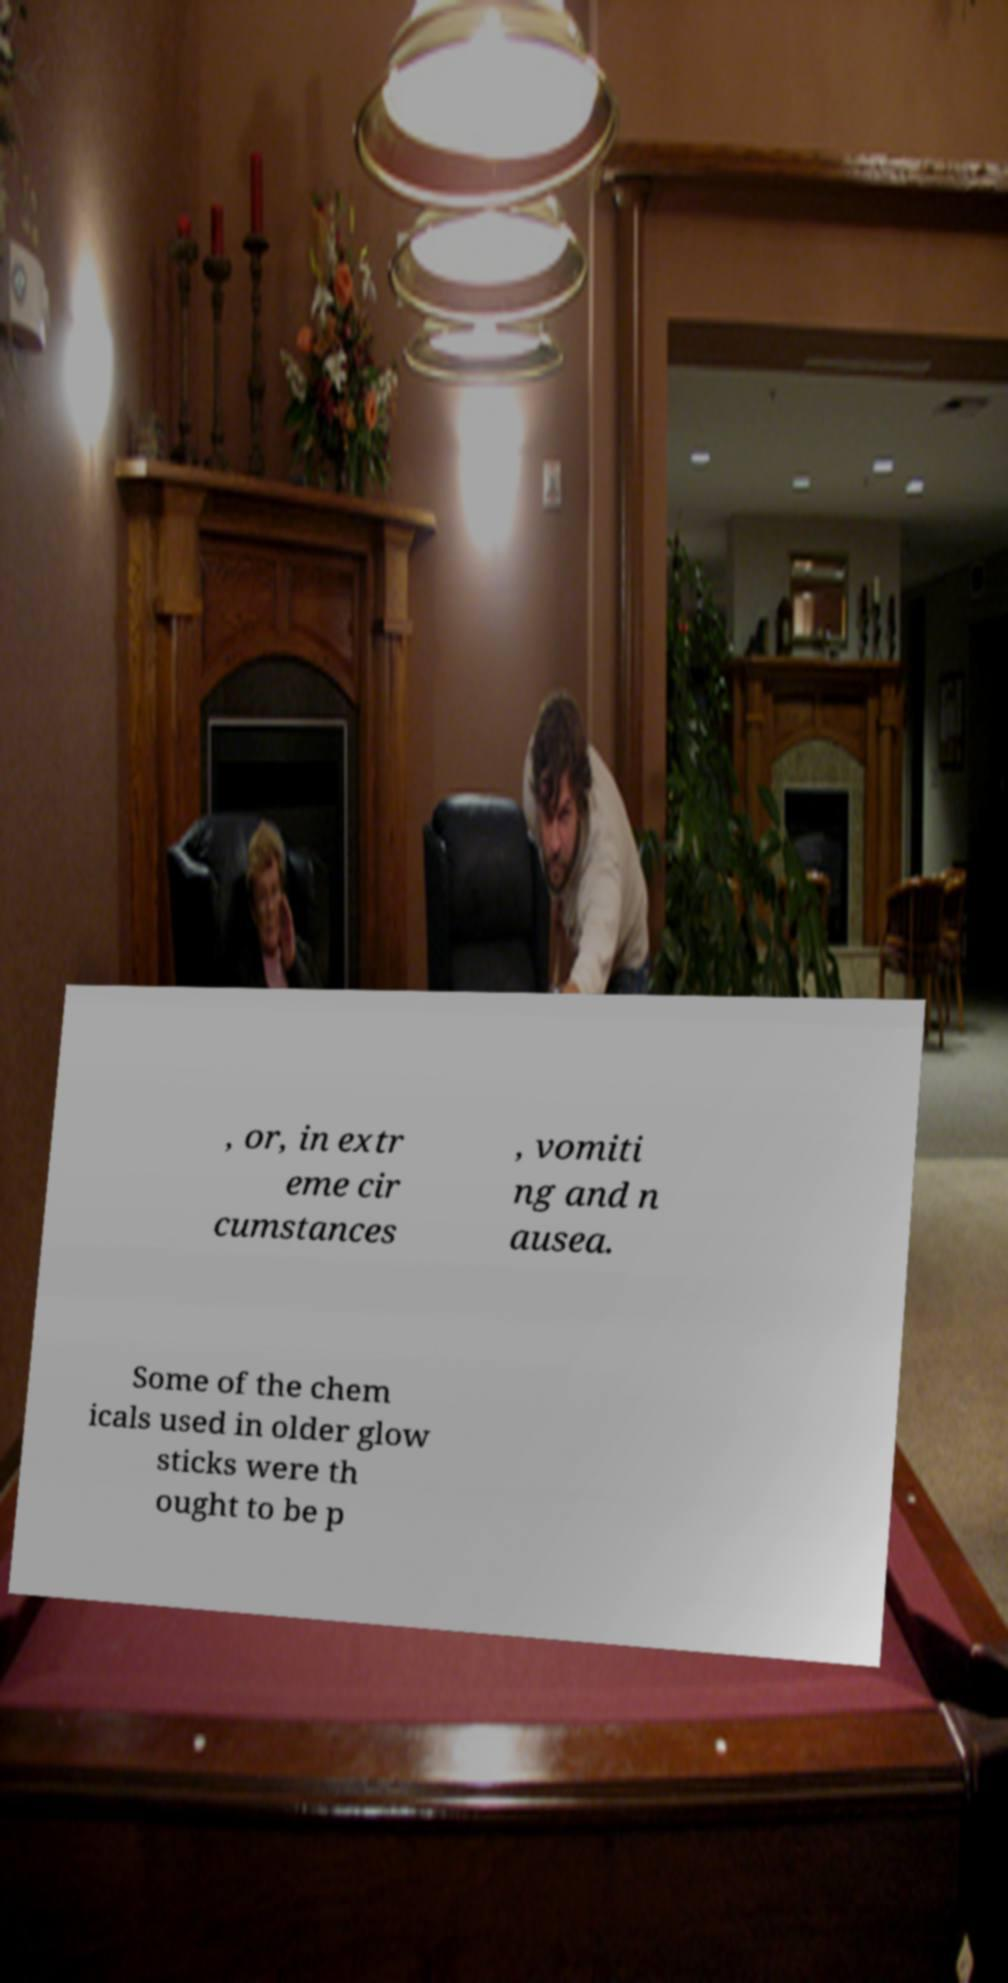There's text embedded in this image that I need extracted. Can you transcribe it verbatim? , or, in extr eme cir cumstances , vomiti ng and n ausea. Some of the chem icals used in older glow sticks were th ought to be p 